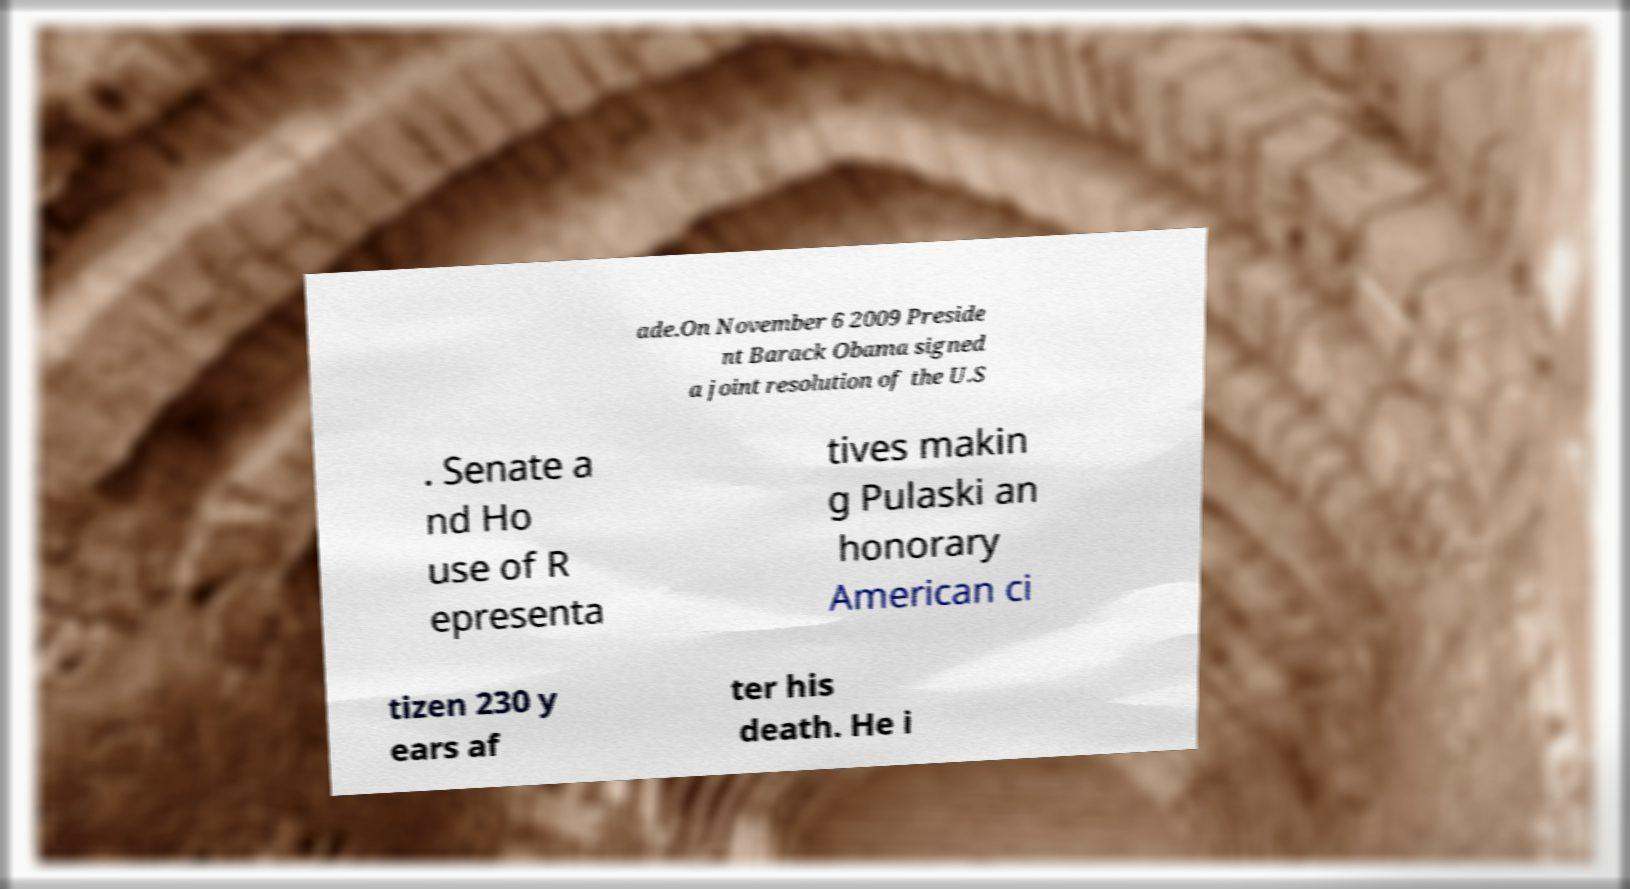Can you read and provide the text displayed in the image?This photo seems to have some interesting text. Can you extract and type it out for me? ade.On November 6 2009 Preside nt Barack Obama signed a joint resolution of the U.S . Senate a nd Ho use of R epresenta tives makin g Pulaski an honorary American ci tizen 230 y ears af ter his death. He i 